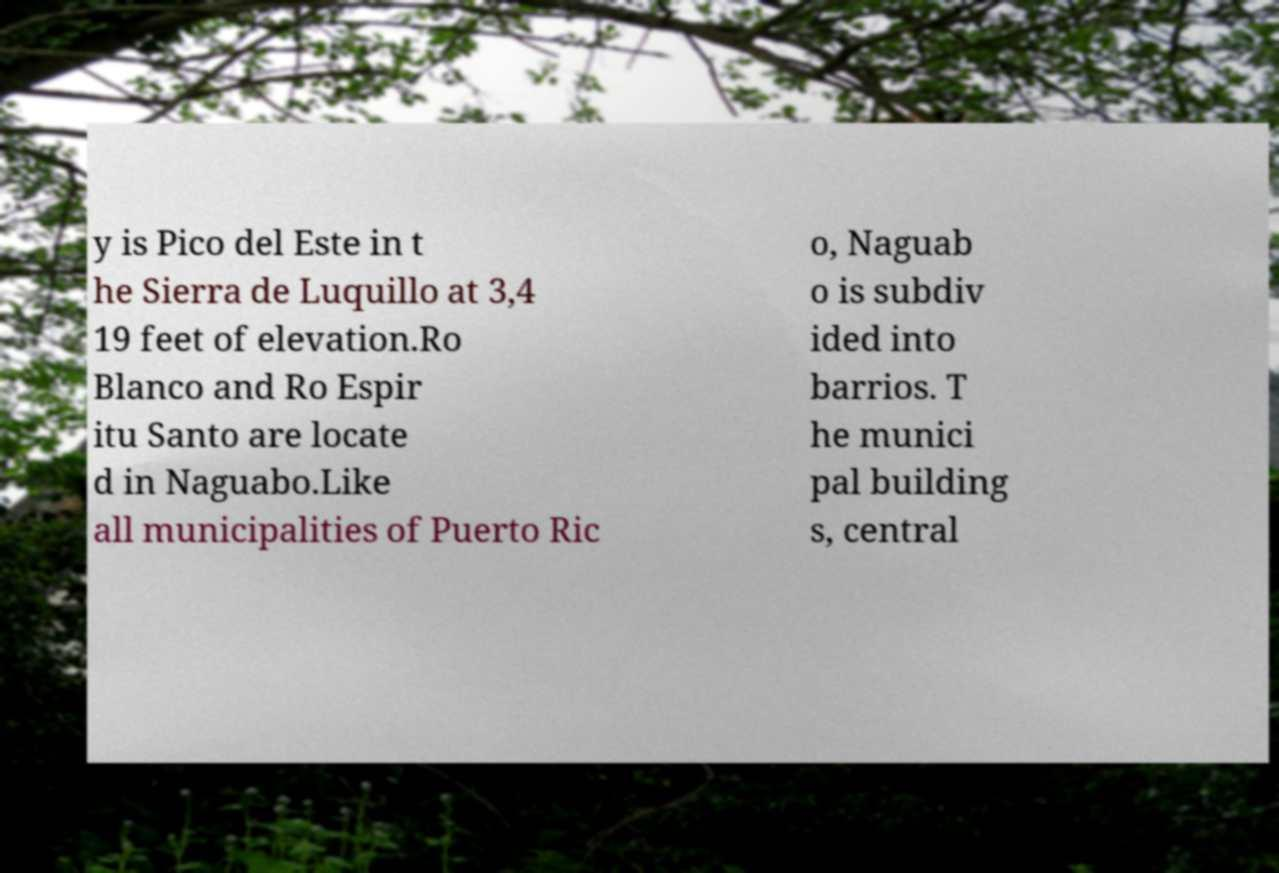What messages or text are displayed in this image? I need them in a readable, typed format. y is Pico del Este in t he Sierra de Luquillo at 3,4 19 feet of elevation.Ro Blanco and Ro Espir itu Santo are locate d in Naguabo.Like all municipalities of Puerto Ric o, Naguab o is subdiv ided into barrios. T he munici pal building s, central 